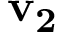<formula> <loc_0><loc_0><loc_500><loc_500>v _ { 2 }</formula> 